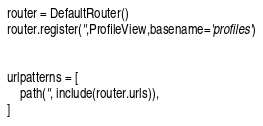Convert code to text. <code><loc_0><loc_0><loc_500><loc_500><_Python_>
router = DefaultRouter()
router.register('',ProfileView,basename='profiles')


urlpatterns = [
    path('', include(router.urls)),
]</code> 